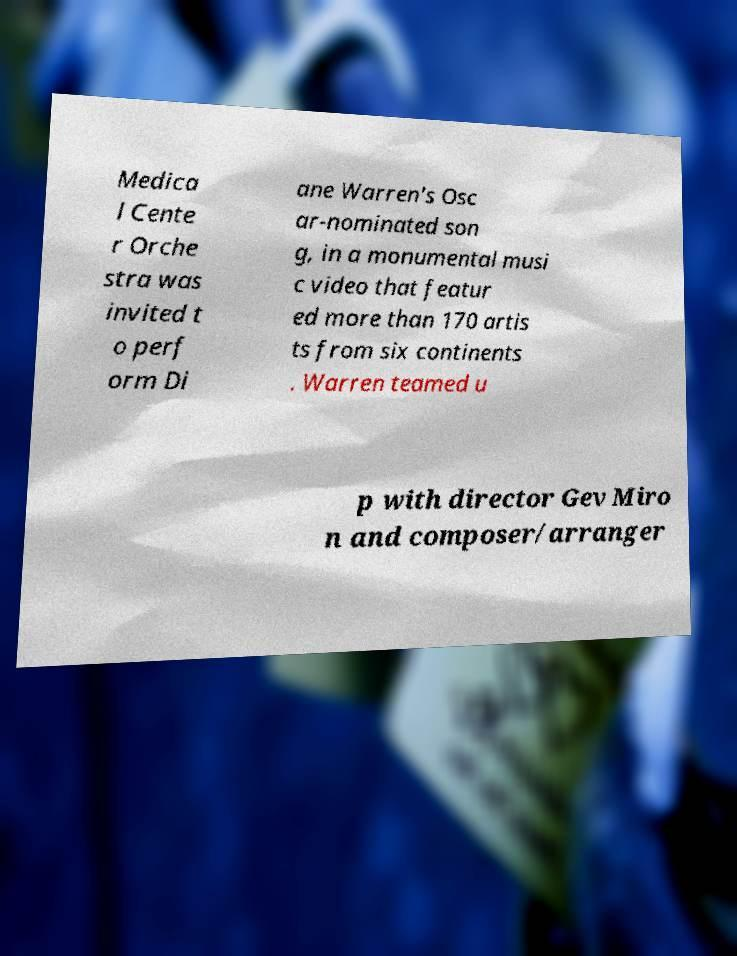Can you read and provide the text displayed in the image?This photo seems to have some interesting text. Can you extract and type it out for me? Medica l Cente r Orche stra was invited t o perf orm Di ane Warren's Osc ar-nominated son g, in a monumental musi c video that featur ed more than 170 artis ts from six continents . Warren teamed u p with director Gev Miro n and composer/arranger 